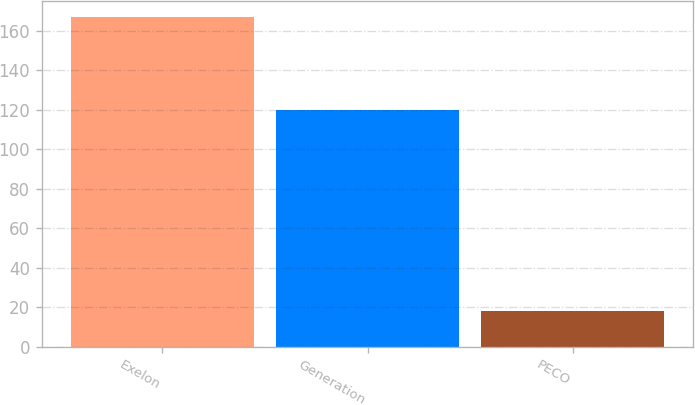Convert chart. <chart><loc_0><loc_0><loc_500><loc_500><bar_chart><fcel>Exelon<fcel>Generation<fcel>PECO<nl><fcel>167<fcel>120<fcel>18<nl></chart> 